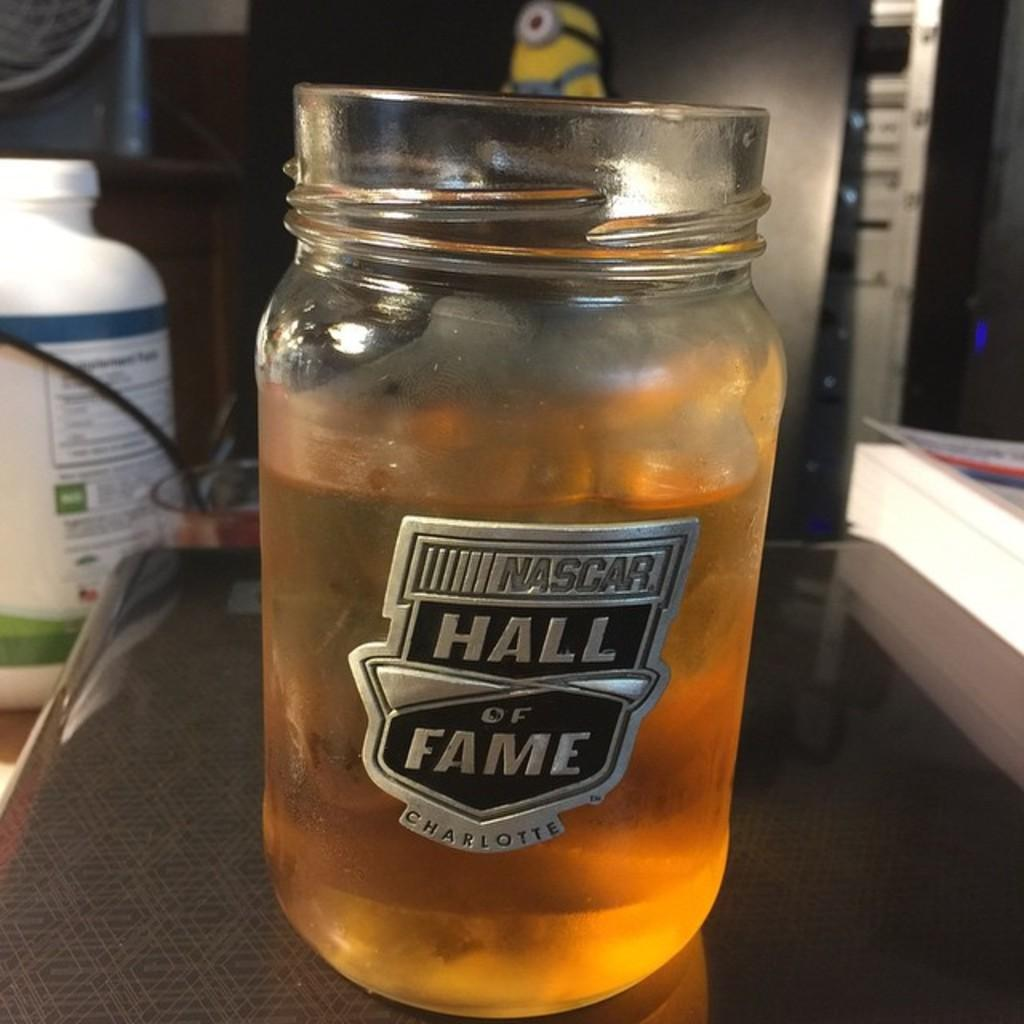What is inside the jar that is visible in the image? There is a drink in the jar that is visible in the image. Where is the jar placed in the image? The jar is placed on a table in the image. What color is the bottle in the background of the image? The bottle in the background of the image is white. What can be seen in the image that is not a part of the jar or the table? There is a wire visible in the image, as well as other objects present in the background. How does the key spark when it blows in the image? There is no key or blowing action present in the image; it only features a jar filled with a drink, a table, a white bottle, a wire, and other objects in the background. 